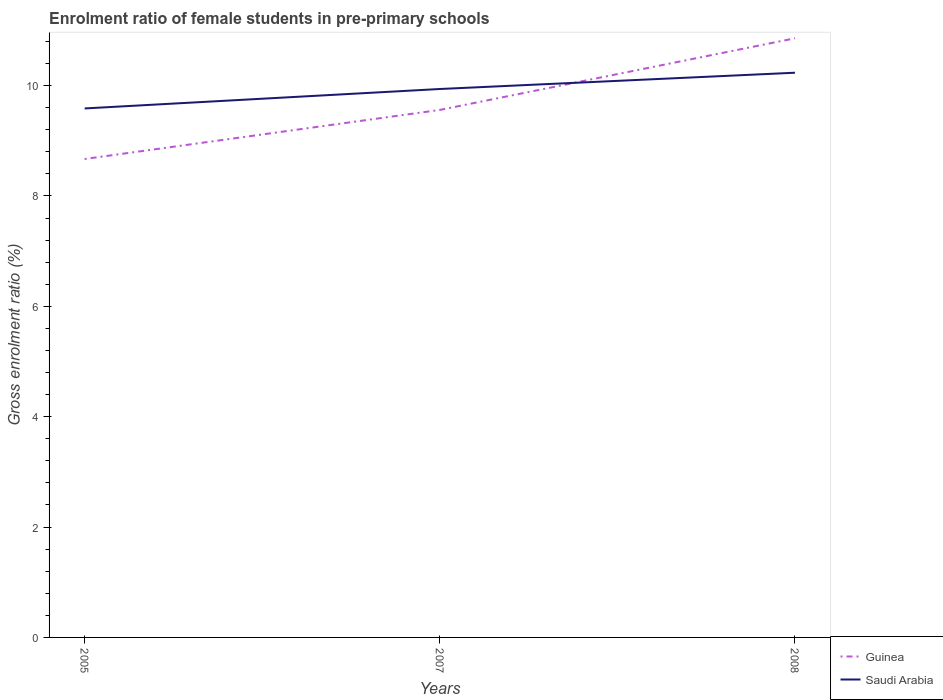How many different coloured lines are there?
Your response must be concise. 2. Across all years, what is the maximum enrolment ratio of female students in pre-primary schools in Guinea?
Offer a terse response. 8.67. What is the total enrolment ratio of female students in pre-primary schools in Saudi Arabia in the graph?
Ensure brevity in your answer.  -0.65. What is the difference between the highest and the second highest enrolment ratio of female students in pre-primary schools in Guinea?
Your answer should be very brief. 2.19. Is the enrolment ratio of female students in pre-primary schools in Guinea strictly greater than the enrolment ratio of female students in pre-primary schools in Saudi Arabia over the years?
Ensure brevity in your answer.  No. How many lines are there?
Ensure brevity in your answer.  2. How many years are there in the graph?
Offer a very short reply. 3. What is the difference between two consecutive major ticks on the Y-axis?
Offer a very short reply. 2. Are the values on the major ticks of Y-axis written in scientific E-notation?
Give a very brief answer. No. Where does the legend appear in the graph?
Provide a succinct answer. Bottom right. What is the title of the graph?
Offer a very short reply. Enrolment ratio of female students in pre-primary schools. What is the label or title of the X-axis?
Offer a very short reply. Years. What is the Gross enrolment ratio (%) in Guinea in 2005?
Your answer should be very brief. 8.67. What is the Gross enrolment ratio (%) of Saudi Arabia in 2005?
Offer a very short reply. 9.59. What is the Gross enrolment ratio (%) in Guinea in 2007?
Your response must be concise. 9.56. What is the Gross enrolment ratio (%) of Saudi Arabia in 2007?
Your answer should be very brief. 9.94. What is the Gross enrolment ratio (%) of Guinea in 2008?
Make the answer very short. 10.86. What is the Gross enrolment ratio (%) of Saudi Arabia in 2008?
Make the answer very short. 10.23. Across all years, what is the maximum Gross enrolment ratio (%) in Guinea?
Give a very brief answer. 10.86. Across all years, what is the maximum Gross enrolment ratio (%) in Saudi Arabia?
Make the answer very short. 10.23. Across all years, what is the minimum Gross enrolment ratio (%) of Guinea?
Ensure brevity in your answer.  8.67. Across all years, what is the minimum Gross enrolment ratio (%) of Saudi Arabia?
Your answer should be very brief. 9.59. What is the total Gross enrolment ratio (%) in Guinea in the graph?
Offer a very short reply. 29.09. What is the total Gross enrolment ratio (%) in Saudi Arabia in the graph?
Ensure brevity in your answer.  29.76. What is the difference between the Gross enrolment ratio (%) in Guinea in 2005 and that in 2007?
Your response must be concise. -0.89. What is the difference between the Gross enrolment ratio (%) in Saudi Arabia in 2005 and that in 2007?
Keep it short and to the point. -0.35. What is the difference between the Gross enrolment ratio (%) of Guinea in 2005 and that in 2008?
Your answer should be very brief. -2.19. What is the difference between the Gross enrolment ratio (%) in Saudi Arabia in 2005 and that in 2008?
Offer a very short reply. -0.65. What is the difference between the Gross enrolment ratio (%) of Guinea in 2007 and that in 2008?
Give a very brief answer. -1.3. What is the difference between the Gross enrolment ratio (%) of Saudi Arabia in 2007 and that in 2008?
Your answer should be compact. -0.29. What is the difference between the Gross enrolment ratio (%) in Guinea in 2005 and the Gross enrolment ratio (%) in Saudi Arabia in 2007?
Make the answer very short. -1.27. What is the difference between the Gross enrolment ratio (%) in Guinea in 2005 and the Gross enrolment ratio (%) in Saudi Arabia in 2008?
Offer a terse response. -1.56. What is the difference between the Gross enrolment ratio (%) of Guinea in 2007 and the Gross enrolment ratio (%) of Saudi Arabia in 2008?
Make the answer very short. -0.67. What is the average Gross enrolment ratio (%) in Guinea per year?
Offer a very short reply. 9.7. What is the average Gross enrolment ratio (%) in Saudi Arabia per year?
Provide a short and direct response. 9.92. In the year 2005, what is the difference between the Gross enrolment ratio (%) of Guinea and Gross enrolment ratio (%) of Saudi Arabia?
Offer a very short reply. -0.92. In the year 2007, what is the difference between the Gross enrolment ratio (%) in Guinea and Gross enrolment ratio (%) in Saudi Arabia?
Provide a succinct answer. -0.38. In the year 2008, what is the difference between the Gross enrolment ratio (%) of Guinea and Gross enrolment ratio (%) of Saudi Arabia?
Provide a short and direct response. 0.62. What is the ratio of the Gross enrolment ratio (%) of Guinea in 2005 to that in 2007?
Your answer should be very brief. 0.91. What is the ratio of the Gross enrolment ratio (%) in Saudi Arabia in 2005 to that in 2007?
Ensure brevity in your answer.  0.96. What is the ratio of the Gross enrolment ratio (%) in Guinea in 2005 to that in 2008?
Offer a very short reply. 0.8. What is the ratio of the Gross enrolment ratio (%) of Saudi Arabia in 2005 to that in 2008?
Provide a short and direct response. 0.94. What is the ratio of the Gross enrolment ratio (%) in Guinea in 2007 to that in 2008?
Provide a succinct answer. 0.88. What is the ratio of the Gross enrolment ratio (%) in Saudi Arabia in 2007 to that in 2008?
Ensure brevity in your answer.  0.97. What is the difference between the highest and the second highest Gross enrolment ratio (%) of Guinea?
Your answer should be very brief. 1.3. What is the difference between the highest and the second highest Gross enrolment ratio (%) of Saudi Arabia?
Your response must be concise. 0.29. What is the difference between the highest and the lowest Gross enrolment ratio (%) of Guinea?
Your answer should be compact. 2.19. What is the difference between the highest and the lowest Gross enrolment ratio (%) of Saudi Arabia?
Offer a terse response. 0.65. 